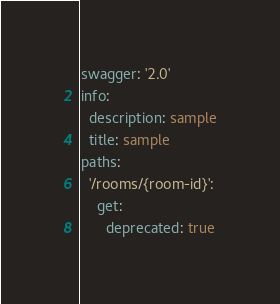Convert code to text. <code><loc_0><loc_0><loc_500><loc_500><_YAML_>swagger: '2.0'
info:
  description: sample
  title: sample
paths:
  '/rooms/{room-id}':
    get:
      deprecated: true</code> 